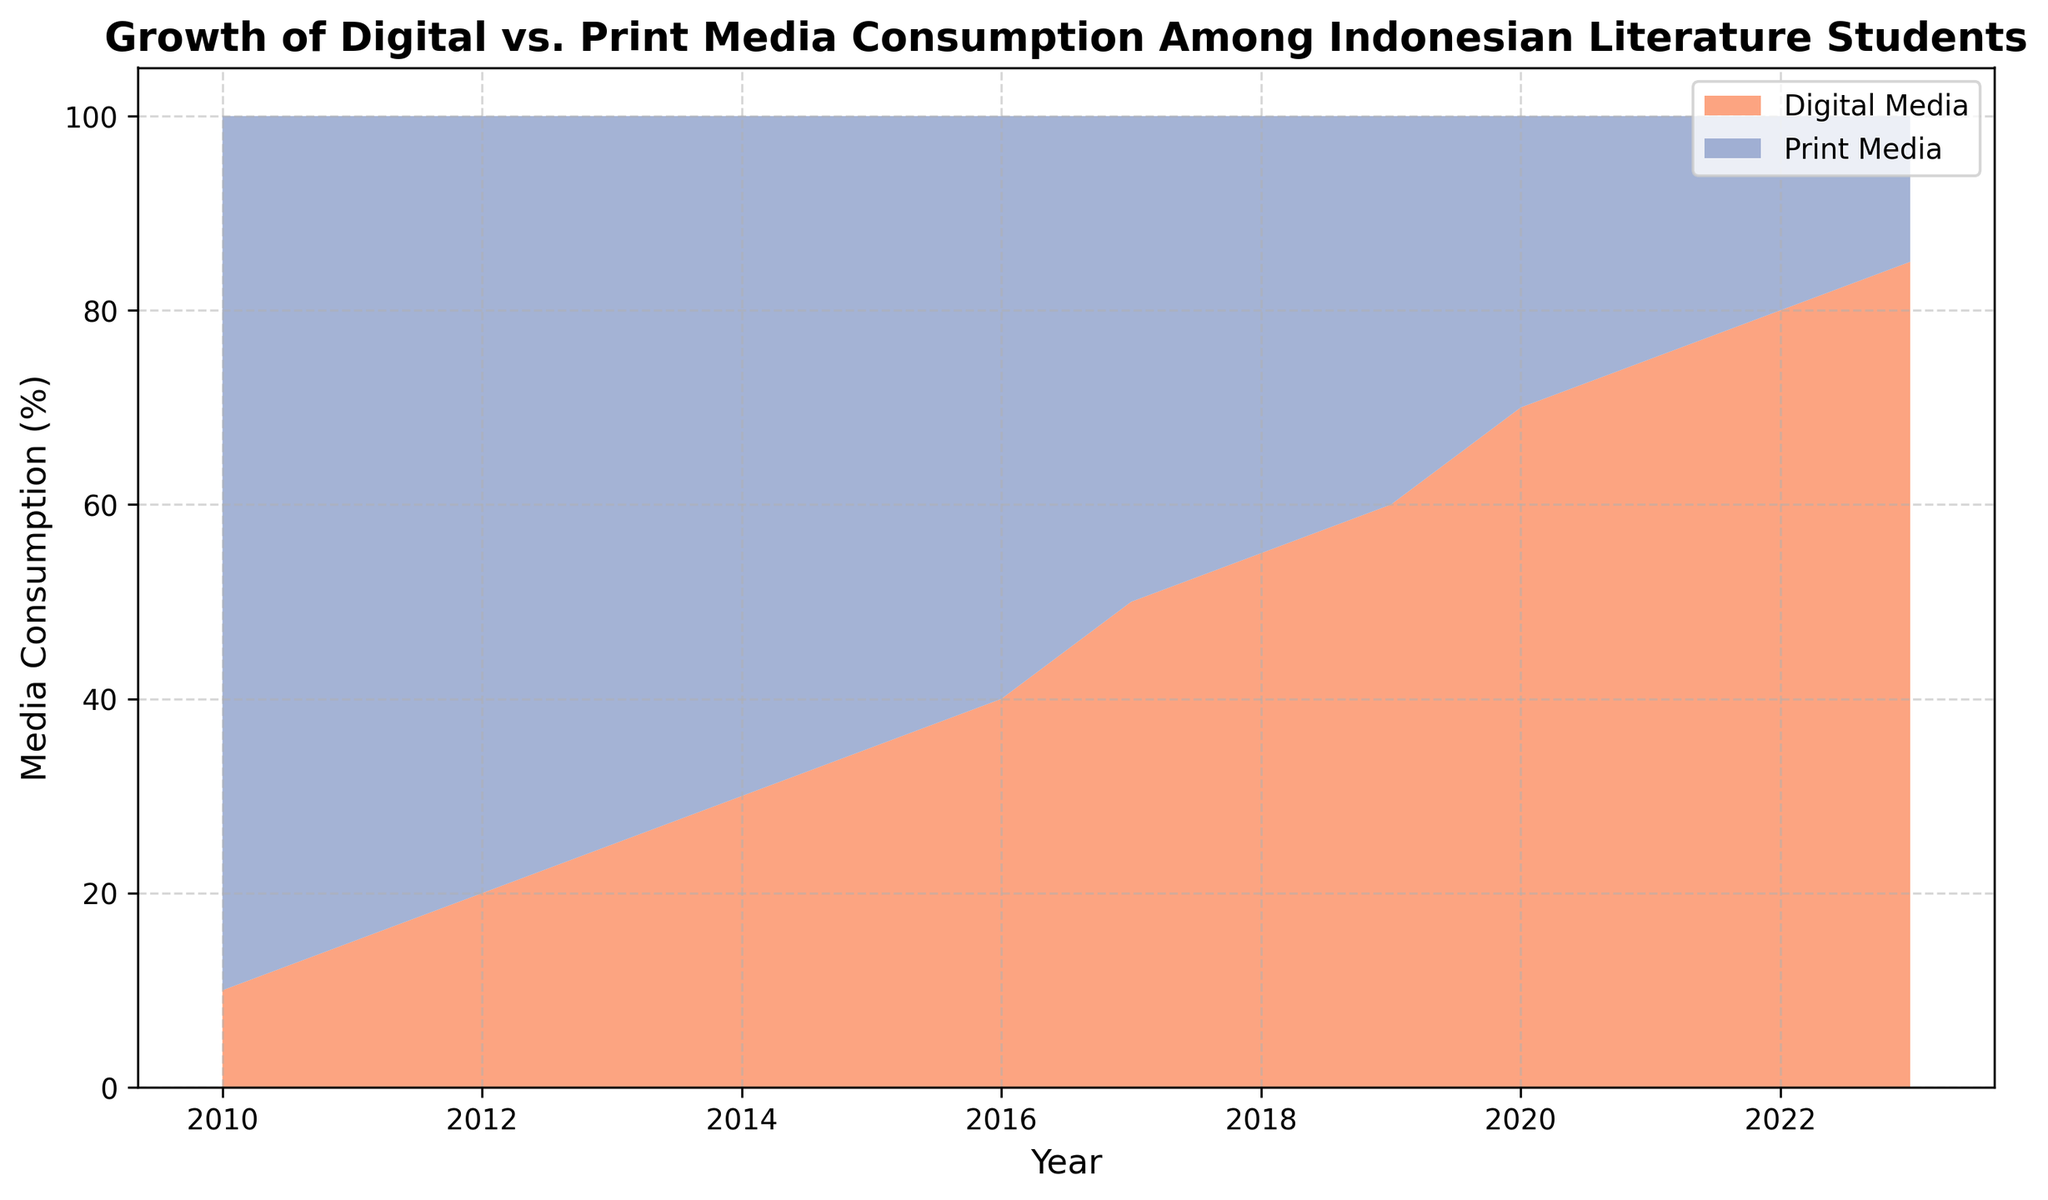What's the percentage of Digital Media consumption in 2010? Look at the data point for the year 2010 in the area chart and find the value where Digital Media consumption is marked.
Answer: 10% Which year did Digital Media consumption surpass Print Media consumption? Observe the X-axis representing the years and identify the point where the area for Digital Media first exceeds the area for Print Media.
Answer: 2017 How much did Digital Media consumption increase between 2010 and 2023? Subtract the Digital Media consumption value at 2010 from the value at 2023. (85% - 10% = 75%)
Answer: 75% What is the trend of Print Media consumption between 2010 and 2023? Analyze the general direction of the line representing Print Media over the years. It shows a consistent downward trend from 90% to 15%.
Answer: Decreasing What was the combined media consumption percentage (Digital + Print) in 2015? Sum the Digital Media and Print Media values for the year 2015. (35% for Digital + 65% for Print = 100%)
Answer: 100% During which period did Digital Media consumption see the steepest increase? Identify the period where the slope of the Digital Media area is the steepest. This occurs between 2016 and 2017.
Answer: 2016-2017 By how much did Print Media consumption decrease from 2012 to 2018? Subtract the Print Media value in 2018 from the value in 2012. (80% - 45% = 35%)
Answer: 35% What was the consumption percentage for both media types in 2020? Refer to the data for the year 2020. Digital Media is 70% and Print Media is 30%.
Answer: Digital Media: 70%, Print Media: 30% How does the consumption of Digital Media in 2021 compare to Print Media in 2015? Use the data for the specific years and compare the values. Digital Media in 2021 is 75%, which is greater than Print Media in 2015, which is 65%.
Answer: Digital Media in 2021 is greater What percentage of total media consumption did Print Media account for in 2023? Look at the value for Print Media in 2023, which is 15%. Since total media consumption is 100%, Print Media is 15% of it.
Answer: 15% 